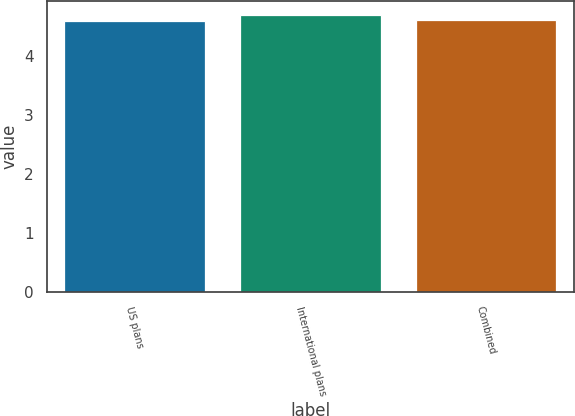Convert chart. <chart><loc_0><loc_0><loc_500><loc_500><bar_chart><fcel>US plans<fcel>International plans<fcel>Combined<nl><fcel>4.6<fcel>4.7<fcel>4.61<nl></chart> 